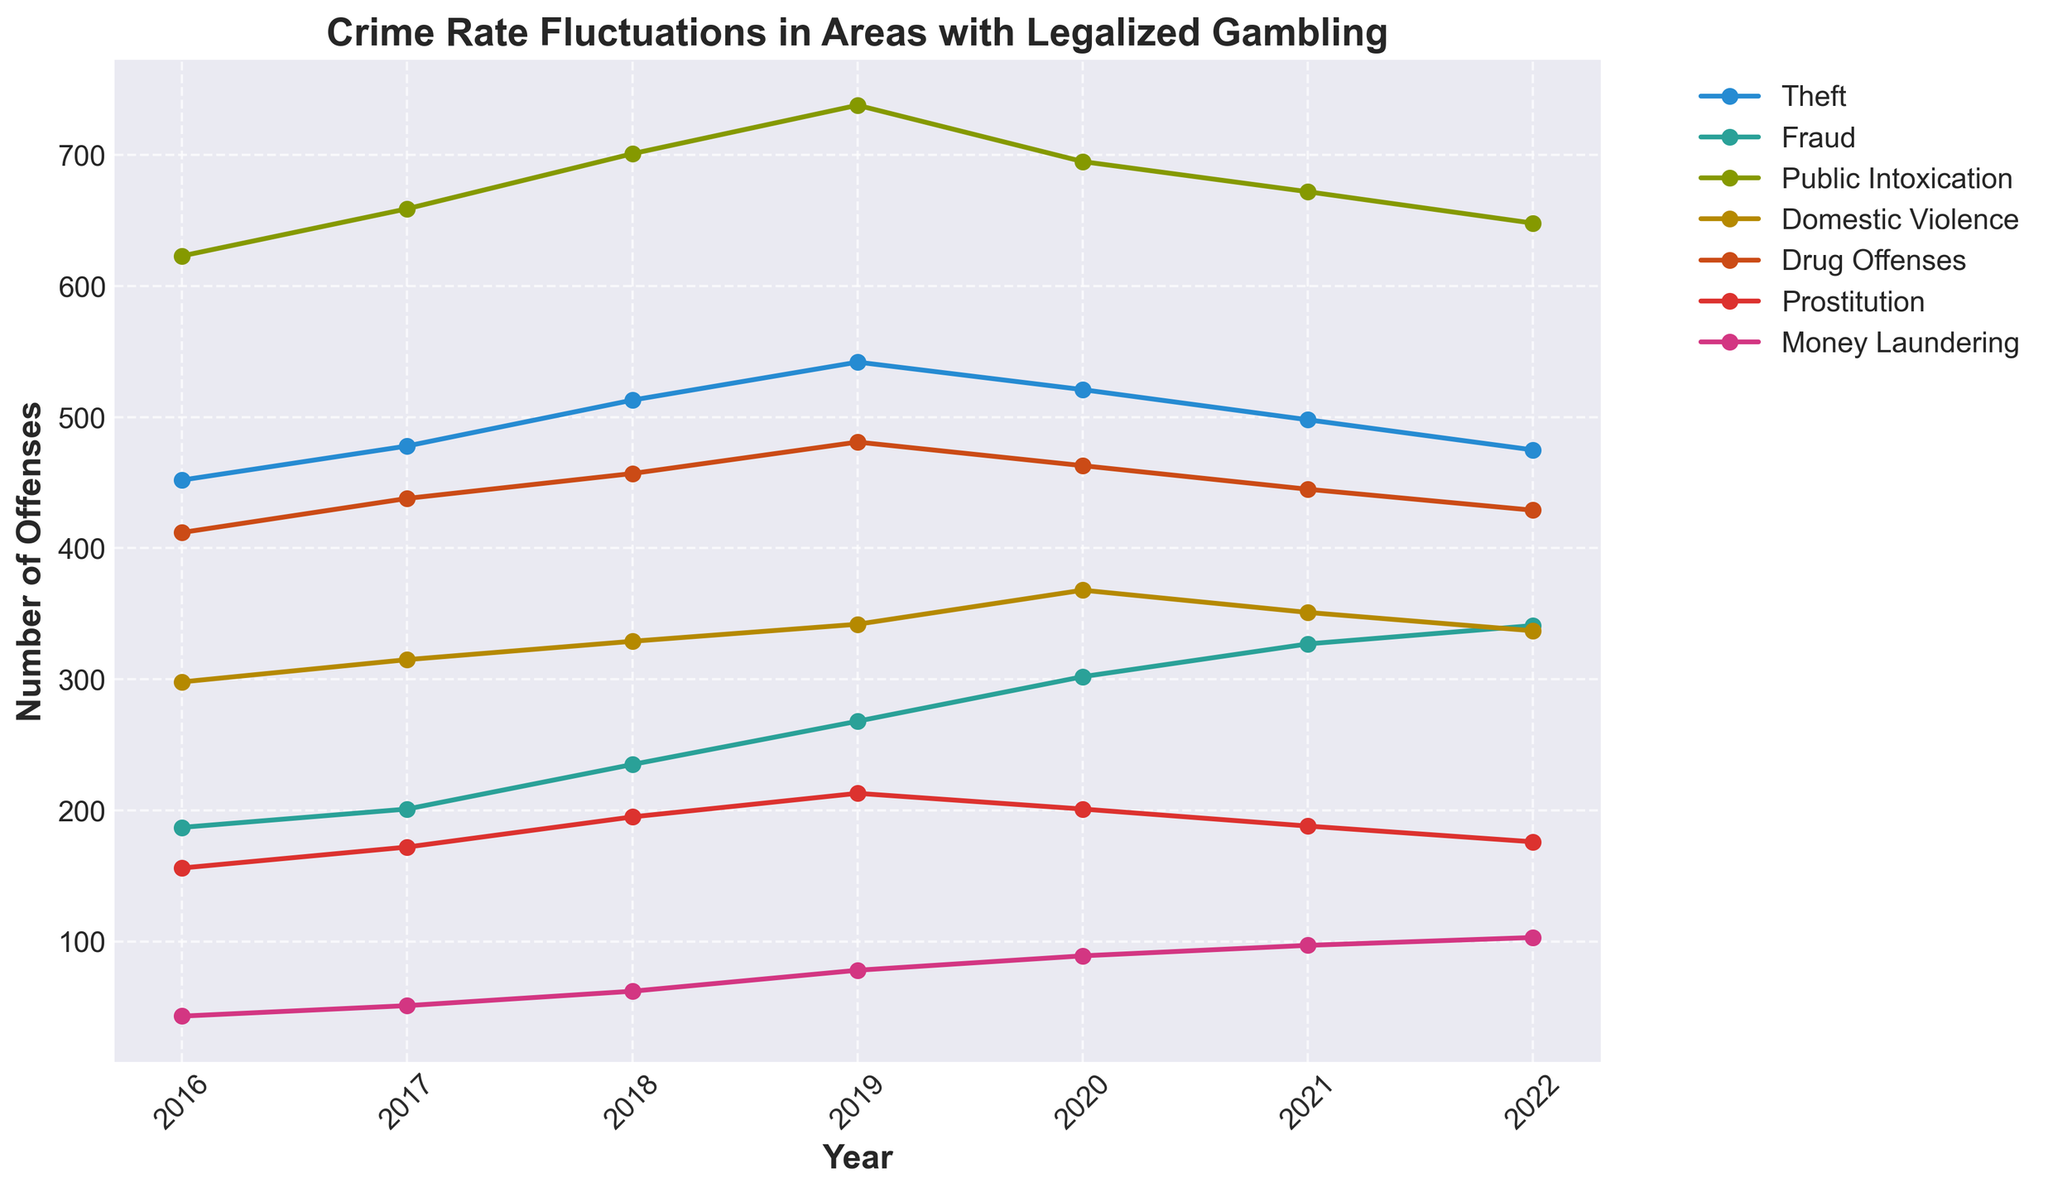What year had the highest number of theft offenses? To identify this, look at the line representing theft. Find the peak point along the x-axis (year) for this line. The highest value occurs in 2019.
Answer: 2019 Which type of offense showed a consistent increase each year from 2016 to 2019? We need to observe the trend lines from 2016 to 2019 and identify one that consistently goes upward without any drops within this period. The 'Theft', 'Fraud', 'Public Intoxication', 'Domestic Violence', 'Drug Offenses', 'Prostitution', and 'Money Laundering' lines all increase consistently up to 2019.
Answer: Multiple offenses (theft, fraud, public intoxication, domestic violence, drug offenses, prostitution, money laundering) Did any type of offense peak in 2020? If so, which one? Check for each offense line to see if 2020 represents the highest point across all years. 'Drug Offenses' and 'Money Laundering' both show their peak values in 2020.
Answer: Drug Offenses, Money Laundering What is the difference in the number of public intoxication offenses between 2016 and 2022? First, find the number of public intoxication offenses in 2016 (623) and in 2022 (648). Subtract the 2016 value from the 2022 value: 648 - 623.
Answer: 25 Which offense had the smallest increase in occurrences from 2016 to 2022? Calculate the difference for each offense from 2016 to 2022, and identify the smallest difference: Theft: 475-452 = 23, Fraud: 341-187 = 154, Public Intoxication: 648-623 = 25, Domestic Violence: 337-298 = 39, Drug Offenses: 429-412 = 17, Prostitution: 176-156 = 20, Money Laundering: 103-43 = 60. The smallest increase is for drug offenses.
Answer: Drug Offenses In which year did domestic violence offenses reach their highest level? Look for the peak in the domestic violence line along the x-axis labeled with years. The highest point is in 2020.
Answer: 2020 Which offense had the largest decrease in occurrences from 2020 to 2022? Calculate the differences for each offense between 2020 and 2022, then identify the largest negative difference: Theft: 521-475 = 46, Fraud: 302-341 = -39, Public Intoxication: 695-648 = 47, Domestic Violence: 368-337 = 31, Drug Offenses: 463-429 = 34, Prostitution: 201-176 = 25, Money Laundering: 89-103 = -14. The largest decrease is in public intoxication.
Answer: Public Intoxication 